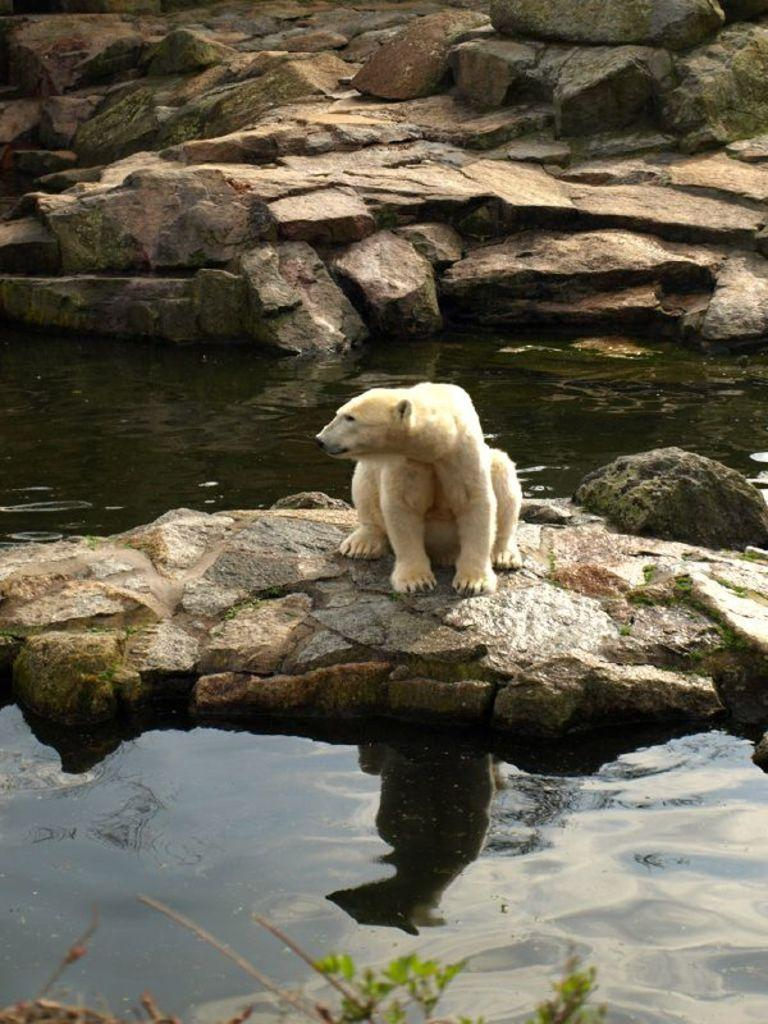What is the primary element visible in the image? There is water in the image. What other objects can be seen in the image? There are rocks in the image. Can you describe the animal in the image? There is a white-colored animal in the image. What type of cord is being used by the animal in the image? There is no cord present in the image, and the animal is not using any. 